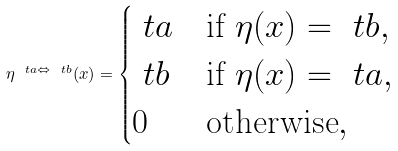Convert formula to latex. <formula><loc_0><loc_0><loc_500><loc_500>\eta ^ { \ t a \Leftrightarrow \ t b } ( x ) = \begin{cases} \ t a & \text {if } \eta ( x ) = \ t b , \\ \ t b & \text {if } \eta ( x ) = \ t a , \\ 0 & \text {otherwise} , \end{cases}</formula> 